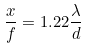<formula> <loc_0><loc_0><loc_500><loc_500>\frac { x } { f } = 1 . 2 2 \frac { \lambda } { d }</formula> 